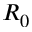Convert formula to latex. <formula><loc_0><loc_0><loc_500><loc_500>R _ { 0 }</formula> 